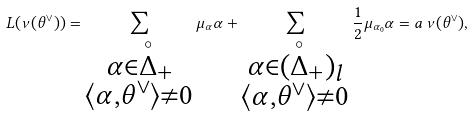Convert formula to latex. <formula><loc_0><loc_0><loc_500><loc_500>L ( \nu ( \theta ^ { \vee } ) ) = \sum _ { \substack { \alpha \in \overset { \circ } { \Delta } _ { + } \\ \langle \alpha , \theta ^ { \vee } \rangle \neq 0 } } \mu _ { \alpha } \alpha + \sum _ { \substack { \alpha \in ( \overset { \circ } { \Delta } _ { + } ) _ { l } \\ \langle \alpha , \theta ^ { \vee } \rangle \neq 0 } } \frac { 1 } { 2 } \mu _ { \alpha _ { 0 } } \alpha = a \, \nu ( \theta ^ { \vee } ) ,</formula> 